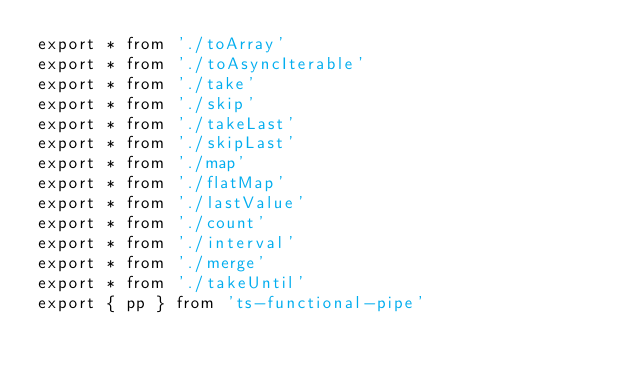Convert code to text. <code><loc_0><loc_0><loc_500><loc_500><_TypeScript_>export * from './toArray'
export * from './toAsyncIterable'
export * from './take'
export * from './skip'
export * from './takeLast'
export * from './skipLast'
export * from './map'
export * from './flatMap'
export * from './lastValue'
export * from './count'
export * from './interval'
export * from './merge'
export * from './takeUntil'
export { pp } from 'ts-functional-pipe'
</code> 